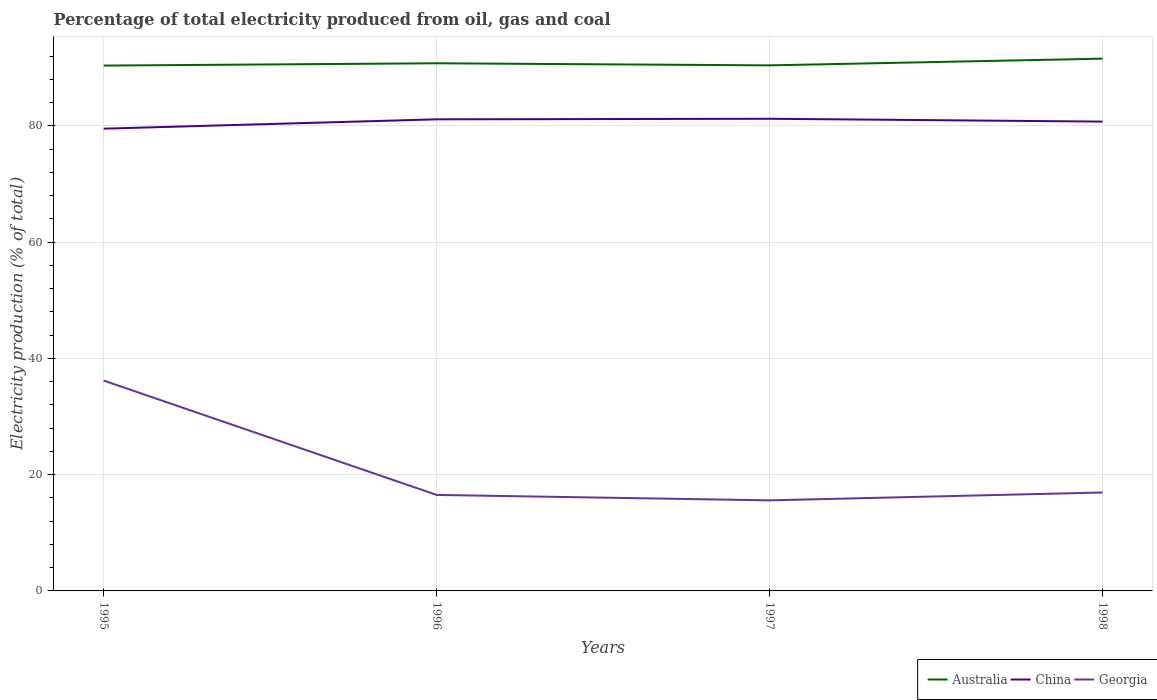Across all years, what is the maximum electricity production in in Australia?
Your response must be concise. 90.38. What is the total electricity production in in China in the graph?
Ensure brevity in your answer.  0.49. What is the difference between the highest and the second highest electricity production in in Georgia?
Make the answer very short. 20.61. How many lines are there?
Keep it short and to the point. 3. How many years are there in the graph?
Offer a terse response. 4. What is the difference between two consecutive major ticks on the Y-axis?
Your response must be concise. 20. What is the title of the graph?
Your answer should be compact. Percentage of total electricity produced from oil, gas and coal. Does "Solomon Islands" appear as one of the legend labels in the graph?
Your answer should be very brief. No. What is the label or title of the X-axis?
Your response must be concise. Years. What is the label or title of the Y-axis?
Your answer should be very brief. Electricity production (% of total). What is the Electricity production (% of total) of Australia in 1995?
Provide a short and direct response. 90.38. What is the Electricity production (% of total) of China in 1995?
Your response must be concise. 79.52. What is the Electricity production (% of total) in Georgia in 1995?
Your answer should be very brief. 36.19. What is the Electricity production (% of total) in Australia in 1996?
Keep it short and to the point. 90.77. What is the Electricity production (% of total) of China in 1996?
Provide a succinct answer. 81.13. What is the Electricity production (% of total) of Georgia in 1996?
Offer a very short reply. 16.52. What is the Electricity production (% of total) in Australia in 1997?
Your response must be concise. 90.41. What is the Electricity production (% of total) of China in 1997?
Provide a short and direct response. 81.23. What is the Electricity production (% of total) in Georgia in 1997?
Your response must be concise. 15.58. What is the Electricity production (% of total) in Australia in 1998?
Offer a terse response. 91.57. What is the Electricity production (% of total) of China in 1998?
Make the answer very short. 80.74. What is the Electricity production (% of total) of Georgia in 1998?
Keep it short and to the point. 16.93. Across all years, what is the maximum Electricity production (% of total) of Australia?
Your response must be concise. 91.57. Across all years, what is the maximum Electricity production (% of total) of China?
Ensure brevity in your answer.  81.23. Across all years, what is the maximum Electricity production (% of total) in Georgia?
Ensure brevity in your answer.  36.19. Across all years, what is the minimum Electricity production (% of total) in Australia?
Offer a terse response. 90.38. Across all years, what is the minimum Electricity production (% of total) of China?
Provide a short and direct response. 79.52. Across all years, what is the minimum Electricity production (% of total) in Georgia?
Make the answer very short. 15.58. What is the total Electricity production (% of total) of Australia in the graph?
Keep it short and to the point. 363.12. What is the total Electricity production (% of total) of China in the graph?
Give a very brief answer. 322.62. What is the total Electricity production (% of total) in Georgia in the graph?
Ensure brevity in your answer.  85.22. What is the difference between the Electricity production (% of total) of Australia in 1995 and that in 1996?
Your response must be concise. -0.39. What is the difference between the Electricity production (% of total) in China in 1995 and that in 1996?
Your response must be concise. -1.61. What is the difference between the Electricity production (% of total) of Georgia in 1995 and that in 1996?
Provide a succinct answer. 19.67. What is the difference between the Electricity production (% of total) in Australia in 1995 and that in 1997?
Ensure brevity in your answer.  -0.04. What is the difference between the Electricity production (% of total) of China in 1995 and that in 1997?
Provide a short and direct response. -1.7. What is the difference between the Electricity production (% of total) of Georgia in 1995 and that in 1997?
Your answer should be very brief. 20.61. What is the difference between the Electricity production (% of total) in Australia in 1995 and that in 1998?
Make the answer very short. -1.19. What is the difference between the Electricity production (% of total) in China in 1995 and that in 1998?
Keep it short and to the point. -1.22. What is the difference between the Electricity production (% of total) of Georgia in 1995 and that in 1998?
Ensure brevity in your answer.  19.26. What is the difference between the Electricity production (% of total) in Australia in 1996 and that in 1997?
Your answer should be compact. 0.36. What is the difference between the Electricity production (% of total) in China in 1996 and that in 1997?
Your answer should be compact. -0.1. What is the difference between the Electricity production (% of total) of Georgia in 1996 and that in 1997?
Keep it short and to the point. 0.94. What is the difference between the Electricity production (% of total) of Australia in 1996 and that in 1998?
Provide a short and direct response. -0.8. What is the difference between the Electricity production (% of total) of China in 1996 and that in 1998?
Give a very brief answer. 0.39. What is the difference between the Electricity production (% of total) of Georgia in 1996 and that in 1998?
Give a very brief answer. -0.42. What is the difference between the Electricity production (% of total) of Australia in 1997 and that in 1998?
Provide a succinct answer. -1.15. What is the difference between the Electricity production (% of total) of China in 1997 and that in 1998?
Give a very brief answer. 0.49. What is the difference between the Electricity production (% of total) in Georgia in 1997 and that in 1998?
Make the answer very short. -1.35. What is the difference between the Electricity production (% of total) in Australia in 1995 and the Electricity production (% of total) in China in 1996?
Provide a succinct answer. 9.25. What is the difference between the Electricity production (% of total) of Australia in 1995 and the Electricity production (% of total) of Georgia in 1996?
Provide a succinct answer. 73.86. What is the difference between the Electricity production (% of total) in China in 1995 and the Electricity production (% of total) in Georgia in 1996?
Your response must be concise. 63.01. What is the difference between the Electricity production (% of total) of Australia in 1995 and the Electricity production (% of total) of China in 1997?
Ensure brevity in your answer.  9.15. What is the difference between the Electricity production (% of total) in Australia in 1995 and the Electricity production (% of total) in Georgia in 1997?
Give a very brief answer. 74.8. What is the difference between the Electricity production (% of total) of China in 1995 and the Electricity production (% of total) of Georgia in 1997?
Keep it short and to the point. 63.94. What is the difference between the Electricity production (% of total) in Australia in 1995 and the Electricity production (% of total) in China in 1998?
Your answer should be very brief. 9.64. What is the difference between the Electricity production (% of total) in Australia in 1995 and the Electricity production (% of total) in Georgia in 1998?
Provide a short and direct response. 73.44. What is the difference between the Electricity production (% of total) of China in 1995 and the Electricity production (% of total) of Georgia in 1998?
Your response must be concise. 62.59. What is the difference between the Electricity production (% of total) in Australia in 1996 and the Electricity production (% of total) in China in 1997?
Provide a short and direct response. 9.54. What is the difference between the Electricity production (% of total) of Australia in 1996 and the Electricity production (% of total) of Georgia in 1997?
Offer a terse response. 75.19. What is the difference between the Electricity production (% of total) of China in 1996 and the Electricity production (% of total) of Georgia in 1997?
Offer a very short reply. 65.55. What is the difference between the Electricity production (% of total) in Australia in 1996 and the Electricity production (% of total) in China in 1998?
Offer a terse response. 10.03. What is the difference between the Electricity production (% of total) of Australia in 1996 and the Electricity production (% of total) of Georgia in 1998?
Give a very brief answer. 73.84. What is the difference between the Electricity production (% of total) in China in 1996 and the Electricity production (% of total) in Georgia in 1998?
Offer a terse response. 64.2. What is the difference between the Electricity production (% of total) in Australia in 1997 and the Electricity production (% of total) in China in 1998?
Offer a terse response. 9.67. What is the difference between the Electricity production (% of total) in Australia in 1997 and the Electricity production (% of total) in Georgia in 1998?
Provide a succinct answer. 73.48. What is the difference between the Electricity production (% of total) of China in 1997 and the Electricity production (% of total) of Georgia in 1998?
Keep it short and to the point. 64.29. What is the average Electricity production (% of total) in Australia per year?
Make the answer very short. 90.78. What is the average Electricity production (% of total) in China per year?
Provide a succinct answer. 80.65. What is the average Electricity production (% of total) in Georgia per year?
Offer a very short reply. 21.31. In the year 1995, what is the difference between the Electricity production (% of total) in Australia and Electricity production (% of total) in China?
Keep it short and to the point. 10.85. In the year 1995, what is the difference between the Electricity production (% of total) of Australia and Electricity production (% of total) of Georgia?
Your answer should be compact. 54.19. In the year 1995, what is the difference between the Electricity production (% of total) in China and Electricity production (% of total) in Georgia?
Offer a very short reply. 43.33. In the year 1996, what is the difference between the Electricity production (% of total) of Australia and Electricity production (% of total) of China?
Your response must be concise. 9.64. In the year 1996, what is the difference between the Electricity production (% of total) of Australia and Electricity production (% of total) of Georgia?
Offer a very short reply. 74.25. In the year 1996, what is the difference between the Electricity production (% of total) in China and Electricity production (% of total) in Georgia?
Offer a very short reply. 64.61. In the year 1997, what is the difference between the Electricity production (% of total) of Australia and Electricity production (% of total) of China?
Your answer should be very brief. 9.19. In the year 1997, what is the difference between the Electricity production (% of total) of Australia and Electricity production (% of total) of Georgia?
Make the answer very short. 74.83. In the year 1997, what is the difference between the Electricity production (% of total) of China and Electricity production (% of total) of Georgia?
Give a very brief answer. 65.65. In the year 1998, what is the difference between the Electricity production (% of total) of Australia and Electricity production (% of total) of China?
Your answer should be compact. 10.83. In the year 1998, what is the difference between the Electricity production (% of total) in Australia and Electricity production (% of total) in Georgia?
Your response must be concise. 74.63. In the year 1998, what is the difference between the Electricity production (% of total) of China and Electricity production (% of total) of Georgia?
Your answer should be compact. 63.81. What is the ratio of the Electricity production (% of total) of Australia in 1995 to that in 1996?
Keep it short and to the point. 1. What is the ratio of the Electricity production (% of total) of China in 1995 to that in 1996?
Provide a short and direct response. 0.98. What is the ratio of the Electricity production (% of total) of Georgia in 1995 to that in 1996?
Your answer should be very brief. 2.19. What is the ratio of the Electricity production (% of total) in Australia in 1995 to that in 1997?
Ensure brevity in your answer.  1. What is the ratio of the Electricity production (% of total) of China in 1995 to that in 1997?
Give a very brief answer. 0.98. What is the ratio of the Electricity production (% of total) in Georgia in 1995 to that in 1997?
Make the answer very short. 2.32. What is the ratio of the Electricity production (% of total) of Australia in 1995 to that in 1998?
Ensure brevity in your answer.  0.99. What is the ratio of the Electricity production (% of total) of China in 1995 to that in 1998?
Ensure brevity in your answer.  0.98. What is the ratio of the Electricity production (% of total) in Georgia in 1995 to that in 1998?
Provide a short and direct response. 2.14. What is the ratio of the Electricity production (% of total) of Australia in 1996 to that in 1997?
Your answer should be very brief. 1. What is the ratio of the Electricity production (% of total) in Georgia in 1996 to that in 1997?
Ensure brevity in your answer.  1.06. What is the ratio of the Electricity production (% of total) of Australia in 1996 to that in 1998?
Offer a very short reply. 0.99. What is the ratio of the Electricity production (% of total) in Georgia in 1996 to that in 1998?
Keep it short and to the point. 0.98. What is the ratio of the Electricity production (% of total) of Australia in 1997 to that in 1998?
Offer a terse response. 0.99. What is the ratio of the Electricity production (% of total) of Georgia in 1997 to that in 1998?
Offer a terse response. 0.92. What is the difference between the highest and the second highest Electricity production (% of total) of Australia?
Your answer should be very brief. 0.8. What is the difference between the highest and the second highest Electricity production (% of total) of China?
Give a very brief answer. 0.1. What is the difference between the highest and the second highest Electricity production (% of total) of Georgia?
Keep it short and to the point. 19.26. What is the difference between the highest and the lowest Electricity production (% of total) in Australia?
Provide a succinct answer. 1.19. What is the difference between the highest and the lowest Electricity production (% of total) in China?
Your response must be concise. 1.7. What is the difference between the highest and the lowest Electricity production (% of total) in Georgia?
Provide a short and direct response. 20.61. 